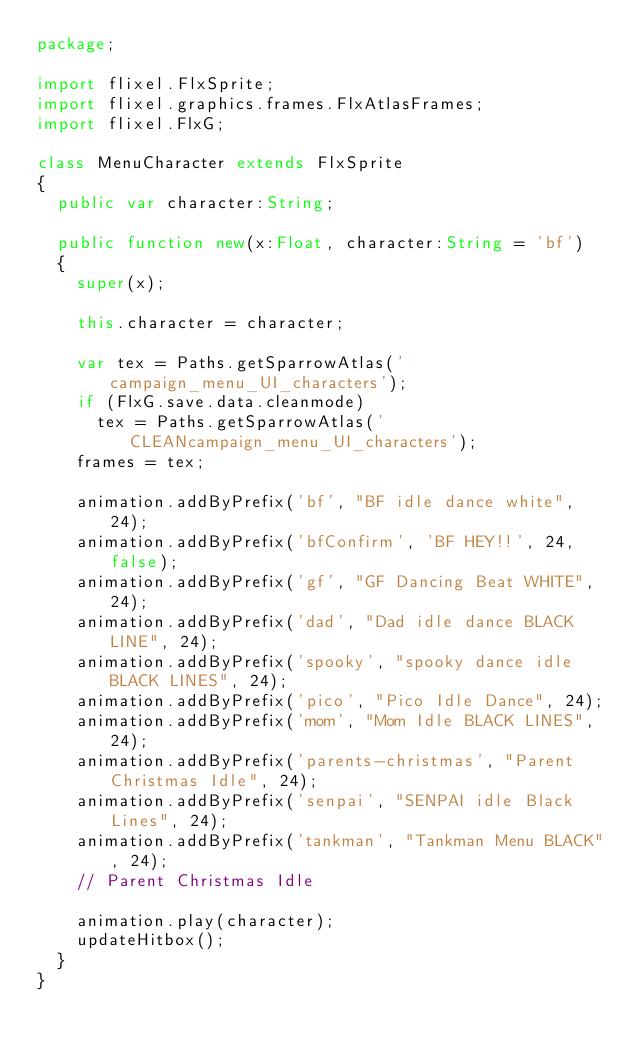Convert code to text. <code><loc_0><loc_0><loc_500><loc_500><_Haxe_>package;

import flixel.FlxSprite;
import flixel.graphics.frames.FlxAtlasFrames;
import flixel.FlxG;

class MenuCharacter extends FlxSprite
{
	public var character:String;

	public function new(x:Float, character:String = 'bf')
	{
		super(x);

		this.character = character;

		var tex = Paths.getSparrowAtlas('campaign_menu_UI_characters');
		if (FlxG.save.data.cleanmode)
			tex = Paths.getSparrowAtlas('CLEANcampaign_menu_UI_characters');
		frames = tex;

		animation.addByPrefix('bf', "BF idle dance white", 24);
		animation.addByPrefix('bfConfirm', 'BF HEY!!', 24, false);
		animation.addByPrefix('gf', "GF Dancing Beat WHITE", 24);
		animation.addByPrefix('dad', "Dad idle dance BLACK LINE", 24);
		animation.addByPrefix('spooky', "spooky dance idle BLACK LINES", 24);
		animation.addByPrefix('pico', "Pico Idle Dance", 24);
		animation.addByPrefix('mom', "Mom Idle BLACK LINES", 24);
		animation.addByPrefix('parents-christmas', "Parent Christmas Idle", 24);
		animation.addByPrefix('senpai', "SENPAI idle Black Lines", 24);
		animation.addByPrefix('tankman', "Tankman Menu BLACK", 24);
		// Parent Christmas Idle

		animation.play(character);
		updateHitbox();
	}
}
</code> 